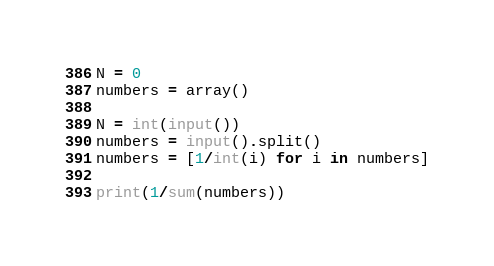<code> <loc_0><loc_0><loc_500><loc_500><_Python_>N = 0
numbers = array()

N = int(input())
numbers = input().split()
numbers = [1/int(i) for i in numbers]

print(1/sum(numbers))
</code> 